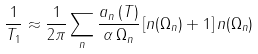<formula> <loc_0><loc_0><loc_500><loc_500>\frac { 1 } { T _ { 1 } } \approx \frac { 1 } { 2 \pi } \sum _ { n } \frac { a _ { n } \left ( T \right ) } { \alpha \, \Omega _ { n } } \left [ n ( \Omega _ { n } ) + 1 \right ] n ( \Omega _ { n } )</formula> 